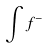Convert formula to latex. <formula><loc_0><loc_0><loc_500><loc_500>\int f ^ { - }</formula> 